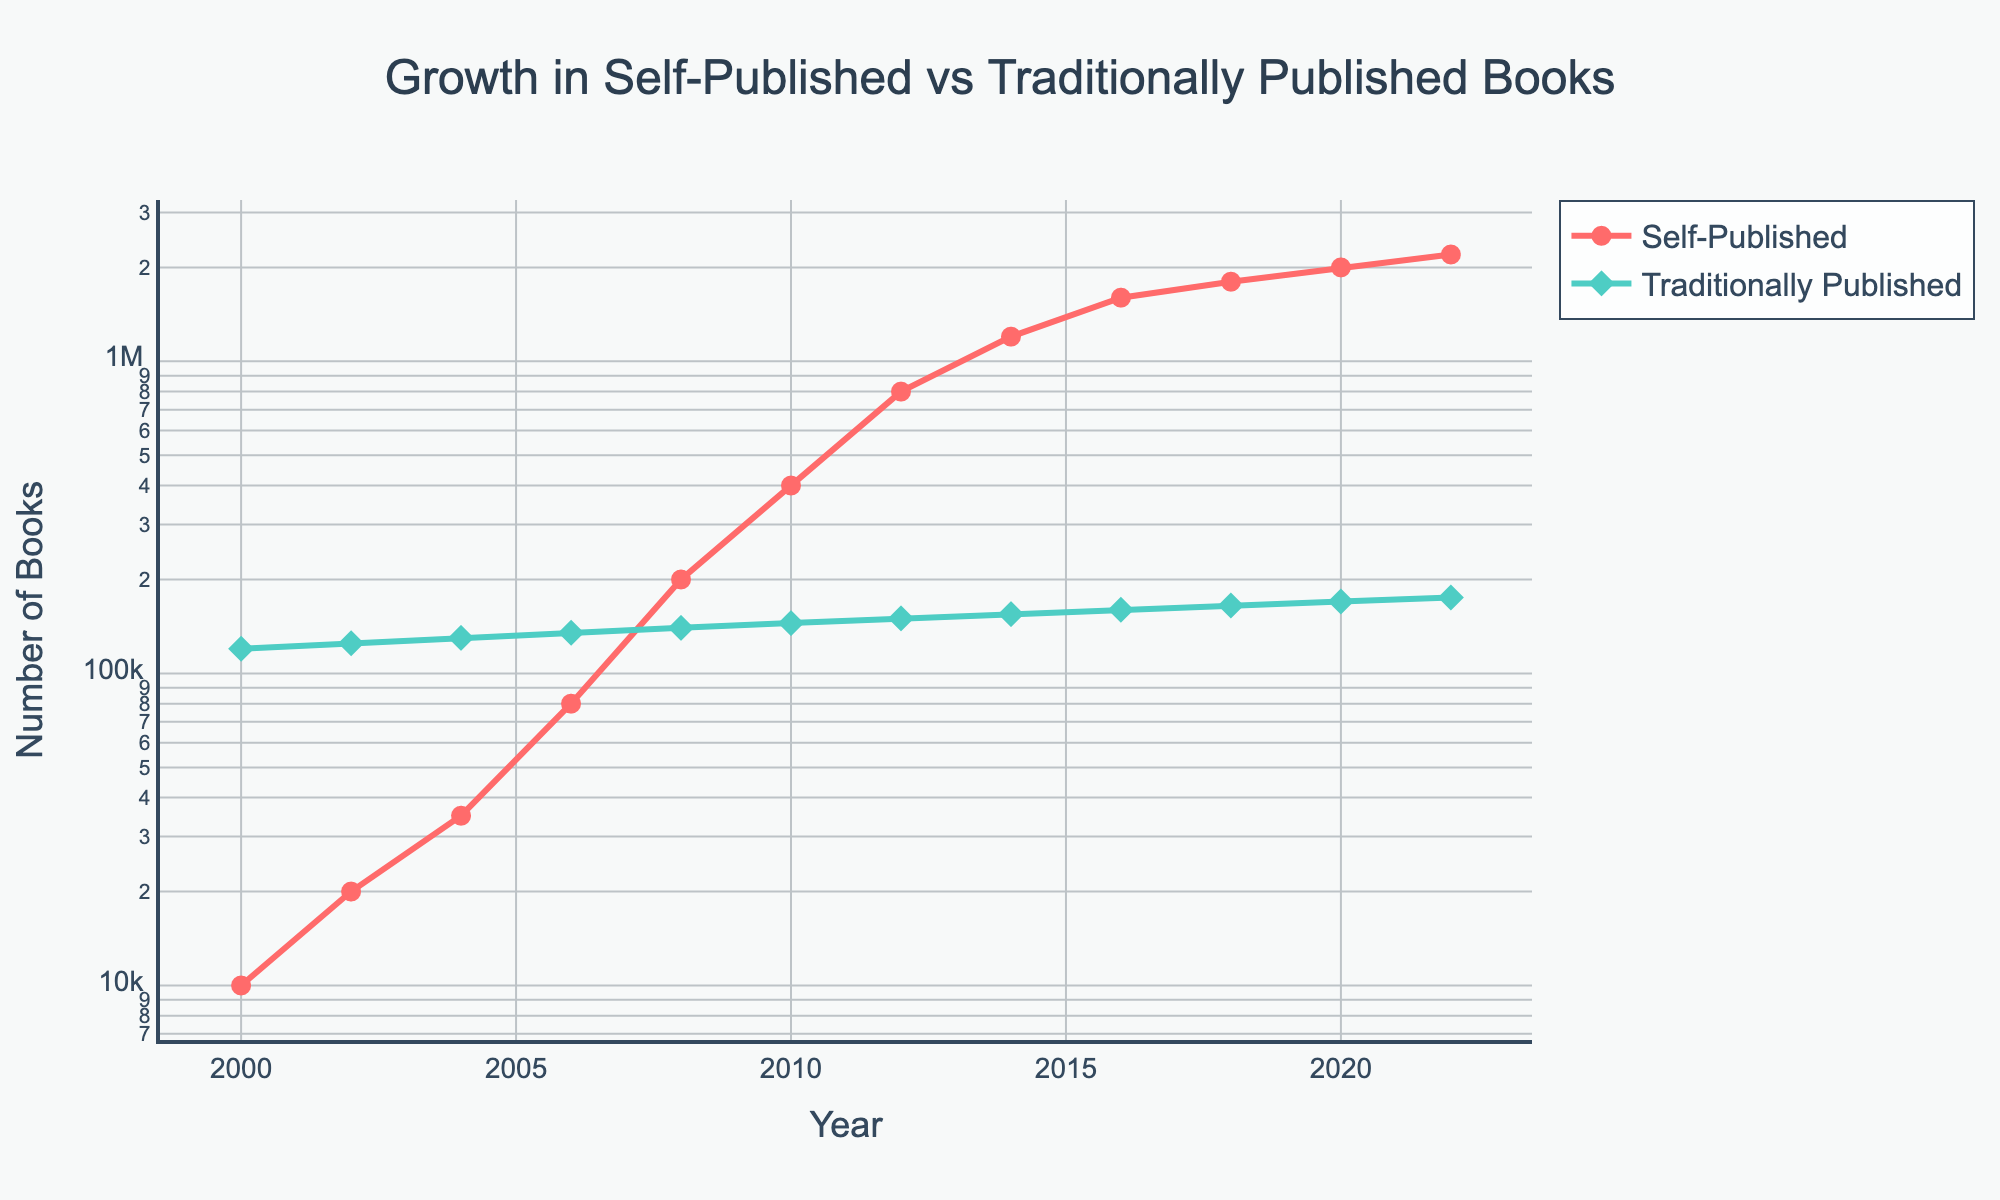What is the overall trend in the number of self-published books from 2000 to 2022? The number of self-published books shows a significant and steady increase over the years, rising from 10,000 in 2000 to 2,200,000 in 2022.
Answer: Steady increase Which year shows the highest number of traditionally published books? The year 2022 shows the highest number of traditionally published books, with 175,000 books published.
Answer: 2022 By how much did the number of self-published books increase between 2010 and 2012? In 2010, there were 400,000 self-published books, and in 2012, there were 800,000 self-published books. The increase is 800,000 - 400,000 = 400,000 books.
Answer: 400,000 Which publication type experienced a greater rate of growth over the period shown and why? Self-published books experienced a greater rate of growth. This is evident because self-published books grew from 10,000 in 2000 to 2,200,000 in 2022, while traditionally published books grew from 120,000 in 2000 to 175,000 in 2022. The former exhibits a significantly higher magnitude of increase.
Answer: Self-published What is the average number of traditionally published books per year between 2000 and 2022? The sum of traditionally published books from 2000 to 2022 is 1,645,000. There are 12 data points, so the average is 1,645,000 / 12 ≈ 137,083.3.
Answer: 137,083.3 How did the number of traditionally published books change between 2000 and 2022? The number of traditionally published books increased from 120,000 in 2000 to 175,000 in 2022.
Answer: Increase Which line in the plot is marked with circles? The line representing the number of self-published books is marked with circles.
Answer: Self-published In what year did the number of self-published books first surpass the number of traditionally published books? The number of self-published books first surpassed the number of traditionally published books in 2008.
Answer: 2008 By what factor did the number of self-published books increase from 2000 to 2022? The number of self-published books increased from 10,000 in 2000 to 2,200,000 in 2022. The factor of increase is 2,200,000 / 10,000 = 220.
Answer: 220 Which publication type had a more stable trend over the years, and how can you tell? Traditionally published books had a more stable trend, showing a gradual and consistent increase rather than the exponential growth seen in self-published books.
Answer: Traditionally published 